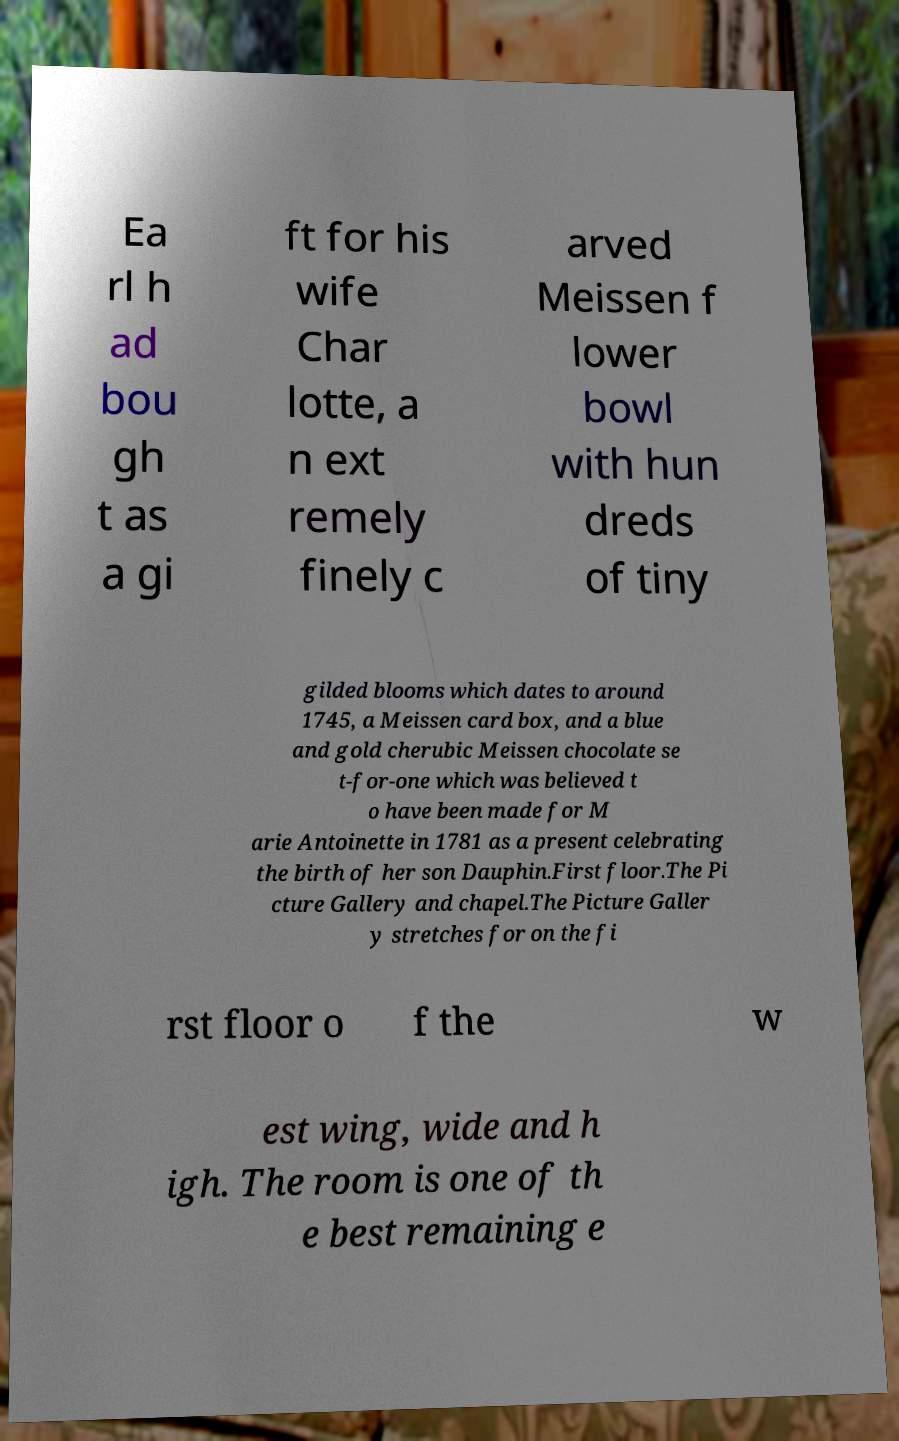Can you accurately transcribe the text from the provided image for me? Ea rl h ad bou gh t as a gi ft for his wife Char lotte, a n ext remely finely c arved Meissen f lower bowl with hun dreds of tiny gilded blooms which dates to around 1745, a Meissen card box, and a blue and gold cherubic Meissen chocolate se t-for-one which was believed t o have been made for M arie Antoinette in 1781 as a present celebrating the birth of her son Dauphin.First floor.The Pi cture Gallery and chapel.The Picture Galler y stretches for on the fi rst floor o f the w est wing, wide and h igh. The room is one of th e best remaining e 